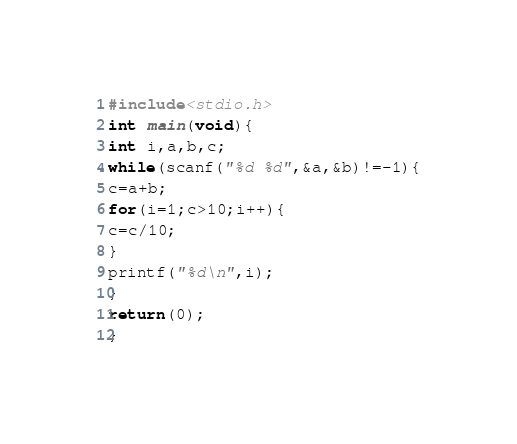Convert code to text. <code><loc_0><loc_0><loc_500><loc_500><_C_>#include<stdio.h>
int main(void){
int i,a,b,c;
while(scanf("%d %d",&a,&b)!=-1){
c=a+b;
for(i=1;c>10;i++){
c=c/10;
}
printf("%d\n",i);
}
return(0);
}</code> 